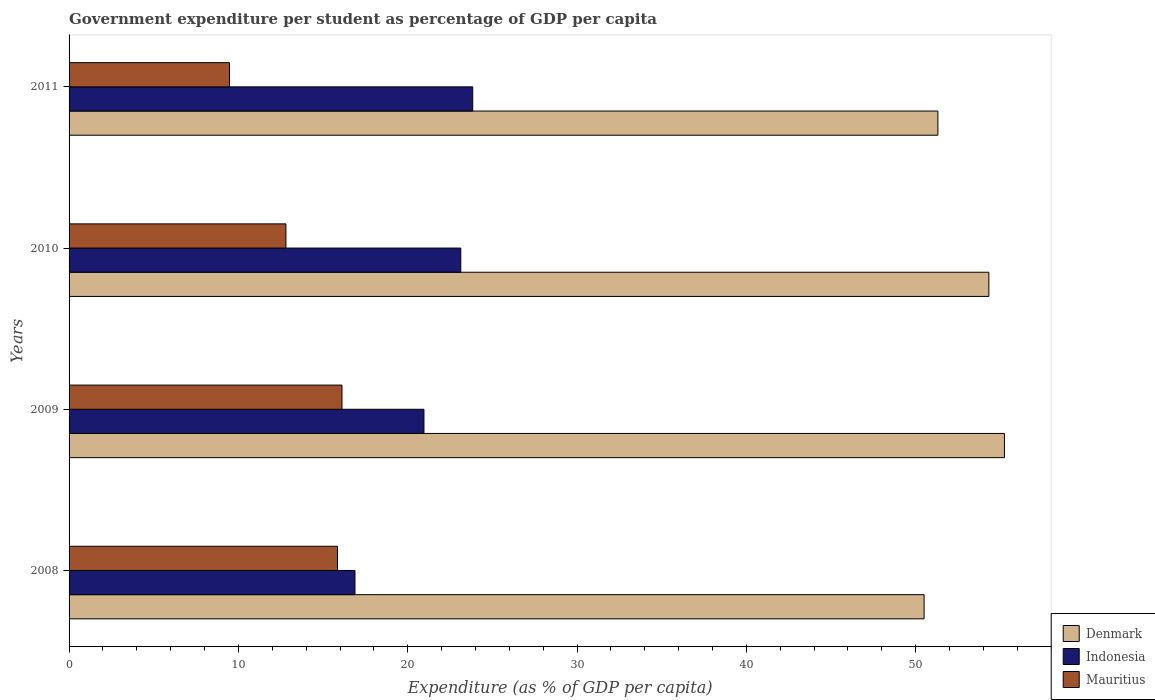Are the number of bars per tick equal to the number of legend labels?
Your answer should be very brief. Yes. What is the percentage of expenditure per student in Denmark in 2009?
Your answer should be very brief. 55.24. Across all years, what is the maximum percentage of expenditure per student in Mauritius?
Your answer should be very brief. 16.12. Across all years, what is the minimum percentage of expenditure per student in Mauritius?
Provide a succinct answer. 9.47. What is the total percentage of expenditure per student in Denmark in the graph?
Offer a very short reply. 211.37. What is the difference between the percentage of expenditure per student in Indonesia in 2009 and that in 2011?
Provide a succinct answer. -2.88. What is the difference between the percentage of expenditure per student in Indonesia in 2010 and the percentage of expenditure per student in Denmark in 2008?
Your answer should be very brief. -27.36. What is the average percentage of expenditure per student in Mauritius per year?
Keep it short and to the point. 13.56. In the year 2011, what is the difference between the percentage of expenditure per student in Indonesia and percentage of expenditure per student in Denmark?
Keep it short and to the point. -27.47. What is the ratio of the percentage of expenditure per student in Denmark in 2010 to that in 2011?
Offer a very short reply. 1.06. Is the percentage of expenditure per student in Denmark in 2009 less than that in 2011?
Offer a very short reply. No. What is the difference between the highest and the second highest percentage of expenditure per student in Indonesia?
Your answer should be compact. 0.7. What is the difference between the highest and the lowest percentage of expenditure per student in Mauritius?
Provide a succinct answer. 6.64. Is the sum of the percentage of expenditure per student in Denmark in 2008 and 2011 greater than the maximum percentage of expenditure per student in Mauritius across all years?
Your response must be concise. Yes. What does the 2nd bar from the top in 2011 represents?
Make the answer very short. Indonesia. What does the 3rd bar from the bottom in 2011 represents?
Provide a succinct answer. Mauritius. How many years are there in the graph?
Make the answer very short. 4. Are the values on the major ticks of X-axis written in scientific E-notation?
Give a very brief answer. No. How many legend labels are there?
Your answer should be very brief. 3. What is the title of the graph?
Keep it short and to the point. Government expenditure per student as percentage of GDP per capita. Does "Sub-Saharan Africa (developing only)" appear as one of the legend labels in the graph?
Your answer should be compact. No. What is the label or title of the X-axis?
Ensure brevity in your answer.  Expenditure (as % of GDP per capita). What is the Expenditure (as % of GDP per capita) in Denmark in 2008?
Your answer should be compact. 50.5. What is the Expenditure (as % of GDP per capita) in Indonesia in 2008?
Your answer should be very brief. 16.89. What is the Expenditure (as % of GDP per capita) of Mauritius in 2008?
Give a very brief answer. 15.85. What is the Expenditure (as % of GDP per capita) of Denmark in 2009?
Your response must be concise. 55.24. What is the Expenditure (as % of GDP per capita) of Indonesia in 2009?
Your answer should be compact. 20.96. What is the Expenditure (as % of GDP per capita) in Mauritius in 2009?
Your response must be concise. 16.12. What is the Expenditure (as % of GDP per capita) of Denmark in 2010?
Make the answer very short. 54.32. What is the Expenditure (as % of GDP per capita) of Indonesia in 2010?
Provide a succinct answer. 23.13. What is the Expenditure (as % of GDP per capita) in Mauritius in 2010?
Make the answer very short. 12.81. What is the Expenditure (as % of GDP per capita) of Denmark in 2011?
Your response must be concise. 51.31. What is the Expenditure (as % of GDP per capita) in Indonesia in 2011?
Your answer should be compact. 23.84. What is the Expenditure (as % of GDP per capita) in Mauritius in 2011?
Your response must be concise. 9.47. Across all years, what is the maximum Expenditure (as % of GDP per capita) in Denmark?
Provide a short and direct response. 55.24. Across all years, what is the maximum Expenditure (as % of GDP per capita) of Indonesia?
Give a very brief answer. 23.84. Across all years, what is the maximum Expenditure (as % of GDP per capita) in Mauritius?
Your response must be concise. 16.12. Across all years, what is the minimum Expenditure (as % of GDP per capita) of Denmark?
Your answer should be very brief. 50.5. Across all years, what is the minimum Expenditure (as % of GDP per capita) of Indonesia?
Offer a terse response. 16.89. Across all years, what is the minimum Expenditure (as % of GDP per capita) in Mauritius?
Your answer should be compact. 9.47. What is the total Expenditure (as % of GDP per capita) in Denmark in the graph?
Your answer should be compact. 211.37. What is the total Expenditure (as % of GDP per capita) of Indonesia in the graph?
Provide a short and direct response. 84.82. What is the total Expenditure (as % of GDP per capita) in Mauritius in the graph?
Offer a terse response. 54.25. What is the difference between the Expenditure (as % of GDP per capita) of Denmark in 2008 and that in 2009?
Offer a terse response. -4.74. What is the difference between the Expenditure (as % of GDP per capita) in Indonesia in 2008 and that in 2009?
Give a very brief answer. -4.07. What is the difference between the Expenditure (as % of GDP per capita) in Mauritius in 2008 and that in 2009?
Your answer should be compact. -0.27. What is the difference between the Expenditure (as % of GDP per capita) in Denmark in 2008 and that in 2010?
Provide a succinct answer. -3.82. What is the difference between the Expenditure (as % of GDP per capita) in Indonesia in 2008 and that in 2010?
Offer a terse response. -6.25. What is the difference between the Expenditure (as % of GDP per capita) in Mauritius in 2008 and that in 2010?
Provide a succinct answer. 3.04. What is the difference between the Expenditure (as % of GDP per capita) in Denmark in 2008 and that in 2011?
Ensure brevity in your answer.  -0.81. What is the difference between the Expenditure (as % of GDP per capita) of Indonesia in 2008 and that in 2011?
Offer a terse response. -6.95. What is the difference between the Expenditure (as % of GDP per capita) of Mauritius in 2008 and that in 2011?
Offer a terse response. 6.38. What is the difference between the Expenditure (as % of GDP per capita) in Denmark in 2009 and that in 2010?
Your answer should be compact. 0.92. What is the difference between the Expenditure (as % of GDP per capita) in Indonesia in 2009 and that in 2010?
Offer a terse response. -2.17. What is the difference between the Expenditure (as % of GDP per capita) in Mauritius in 2009 and that in 2010?
Keep it short and to the point. 3.31. What is the difference between the Expenditure (as % of GDP per capita) in Denmark in 2009 and that in 2011?
Your response must be concise. 3.93. What is the difference between the Expenditure (as % of GDP per capita) of Indonesia in 2009 and that in 2011?
Offer a very short reply. -2.88. What is the difference between the Expenditure (as % of GDP per capita) of Mauritius in 2009 and that in 2011?
Your answer should be very brief. 6.64. What is the difference between the Expenditure (as % of GDP per capita) of Denmark in 2010 and that in 2011?
Provide a succinct answer. 3.01. What is the difference between the Expenditure (as % of GDP per capita) in Indonesia in 2010 and that in 2011?
Provide a succinct answer. -0.7. What is the difference between the Expenditure (as % of GDP per capita) of Mauritius in 2010 and that in 2011?
Your answer should be compact. 3.33. What is the difference between the Expenditure (as % of GDP per capita) of Denmark in 2008 and the Expenditure (as % of GDP per capita) of Indonesia in 2009?
Ensure brevity in your answer.  29.54. What is the difference between the Expenditure (as % of GDP per capita) of Denmark in 2008 and the Expenditure (as % of GDP per capita) of Mauritius in 2009?
Give a very brief answer. 34.38. What is the difference between the Expenditure (as % of GDP per capita) of Indonesia in 2008 and the Expenditure (as % of GDP per capita) of Mauritius in 2009?
Provide a short and direct response. 0.77. What is the difference between the Expenditure (as % of GDP per capita) in Denmark in 2008 and the Expenditure (as % of GDP per capita) in Indonesia in 2010?
Keep it short and to the point. 27.36. What is the difference between the Expenditure (as % of GDP per capita) in Denmark in 2008 and the Expenditure (as % of GDP per capita) in Mauritius in 2010?
Ensure brevity in your answer.  37.69. What is the difference between the Expenditure (as % of GDP per capita) in Indonesia in 2008 and the Expenditure (as % of GDP per capita) in Mauritius in 2010?
Make the answer very short. 4.08. What is the difference between the Expenditure (as % of GDP per capita) of Denmark in 2008 and the Expenditure (as % of GDP per capita) of Indonesia in 2011?
Your answer should be very brief. 26.66. What is the difference between the Expenditure (as % of GDP per capita) in Denmark in 2008 and the Expenditure (as % of GDP per capita) in Mauritius in 2011?
Your response must be concise. 41.02. What is the difference between the Expenditure (as % of GDP per capita) in Indonesia in 2008 and the Expenditure (as % of GDP per capita) in Mauritius in 2011?
Your answer should be compact. 7.41. What is the difference between the Expenditure (as % of GDP per capita) in Denmark in 2009 and the Expenditure (as % of GDP per capita) in Indonesia in 2010?
Offer a very short reply. 32.11. What is the difference between the Expenditure (as % of GDP per capita) in Denmark in 2009 and the Expenditure (as % of GDP per capita) in Mauritius in 2010?
Your answer should be compact. 42.43. What is the difference between the Expenditure (as % of GDP per capita) in Indonesia in 2009 and the Expenditure (as % of GDP per capita) in Mauritius in 2010?
Provide a succinct answer. 8.15. What is the difference between the Expenditure (as % of GDP per capita) in Denmark in 2009 and the Expenditure (as % of GDP per capita) in Indonesia in 2011?
Your response must be concise. 31.4. What is the difference between the Expenditure (as % of GDP per capita) of Denmark in 2009 and the Expenditure (as % of GDP per capita) of Mauritius in 2011?
Provide a succinct answer. 45.77. What is the difference between the Expenditure (as % of GDP per capita) of Indonesia in 2009 and the Expenditure (as % of GDP per capita) of Mauritius in 2011?
Ensure brevity in your answer.  11.49. What is the difference between the Expenditure (as % of GDP per capita) in Denmark in 2010 and the Expenditure (as % of GDP per capita) in Indonesia in 2011?
Offer a terse response. 30.48. What is the difference between the Expenditure (as % of GDP per capita) in Denmark in 2010 and the Expenditure (as % of GDP per capita) in Mauritius in 2011?
Offer a very short reply. 44.85. What is the difference between the Expenditure (as % of GDP per capita) of Indonesia in 2010 and the Expenditure (as % of GDP per capita) of Mauritius in 2011?
Give a very brief answer. 13.66. What is the average Expenditure (as % of GDP per capita) of Denmark per year?
Make the answer very short. 52.84. What is the average Expenditure (as % of GDP per capita) in Indonesia per year?
Offer a terse response. 21.2. What is the average Expenditure (as % of GDP per capita) in Mauritius per year?
Ensure brevity in your answer.  13.56. In the year 2008, what is the difference between the Expenditure (as % of GDP per capita) of Denmark and Expenditure (as % of GDP per capita) of Indonesia?
Your response must be concise. 33.61. In the year 2008, what is the difference between the Expenditure (as % of GDP per capita) of Denmark and Expenditure (as % of GDP per capita) of Mauritius?
Give a very brief answer. 34.65. In the year 2008, what is the difference between the Expenditure (as % of GDP per capita) in Indonesia and Expenditure (as % of GDP per capita) in Mauritius?
Keep it short and to the point. 1.03. In the year 2009, what is the difference between the Expenditure (as % of GDP per capita) in Denmark and Expenditure (as % of GDP per capita) in Indonesia?
Make the answer very short. 34.28. In the year 2009, what is the difference between the Expenditure (as % of GDP per capita) in Denmark and Expenditure (as % of GDP per capita) in Mauritius?
Provide a short and direct response. 39.12. In the year 2009, what is the difference between the Expenditure (as % of GDP per capita) in Indonesia and Expenditure (as % of GDP per capita) in Mauritius?
Offer a very short reply. 4.84. In the year 2010, what is the difference between the Expenditure (as % of GDP per capita) of Denmark and Expenditure (as % of GDP per capita) of Indonesia?
Give a very brief answer. 31.19. In the year 2010, what is the difference between the Expenditure (as % of GDP per capita) of Denmark and Expenditure (as % of GDP per capita) of Mauritius?
Provide a short and direct response. 41.51. In the year 2010, what is the difference between the Expenditure (as % of GDP per capita) in Indonesia and Expenditure (as % of GDP per capita) in Mauritius?
Offer a very short reply. 10.33. In the year 2011, what is the difference between the Expenditure (as % of GDP per capita) of Denmark and Expenditure (as % of GDP per capita) of Indonesia?
Offer a very short reply. 27.47. In the year 2011, what is the difference between the Expenditure (as % of GDP per capita) in Denmark and Expenditure (as % of GDP per capita) in Mauritius?
Provide a succinct answer. 41.84. In the year 2011, what is the difference between the Expenditure (as % of GDP per capita) in Indonesia and Expenditure (as % of GDP per capita) in Mauritius?
Give a very brief answer. 14.36. What is the ratio of the Expenditure (as % of GDP per capita) in Denmark in 2008 to that in 2009?
Offer a very short reply. 0.91. What is the ratio of the Expenditure (as % of GDP per capita) in Indonesia in 2008 to that in 2009?
Your answer should be very brief. 0.81. What is the ratio of the Expenditure (as % of GDP per capita) of Mauritius in 2008 to that in 2009?
Offer a very short reply. 0.98. What is the ratio of the Expenditure (as % of GDP per capita) in Denmark in 2008 to that in 2010?
Offer a terse response. 0.93. What is the ratio of the Expenditure (as % of GDP per capita) of Indonesia in 2008 to that in 2010?
Make the answer very short. 0.73. What is the ratio of the Expenditure (as % of GDP per capita) in Mauritius in 2008 to that in 2010?
Provide a succinct answer. 1.24. What is the ratio of the Expenditure (as % of GDP per capita) in Denmark in 2008 to that in 2011?
Your answer should be compact. 0.98. What is the ratio of the Expenditure (as % of GDP per capita) of Indonesia in 2008 to that in 2011?
Your response must be concise. 0.71. What is the ratio of the Expenditure (as % of GDP per capita) in Mauritius in 2008 to that in 2011?
Your answer should be very brief. 1.67. What is the ratio of the Expenditure (as % of GDP per capita) in Denmark in 2009 to that in 2010?
Your response must be concise. 1.02. What is the ratio of the Expenditure (as % of GDP per capita) in Indonesia in 2009 to that in 2010?
Your answer should be compact. 0.91. What is the ratio of the Expenditure (as % of GDP per capita) of Mauritius in 2009 to that in 2010?
Offer a terse response. 1.26. What is the ratio of the Expenditure (as % of GDP per capita) of Denmark in 2009 to that in 2011?
Keep it short and to the point. 1.08. What is the ratio of the Expenditure (as % of GDP per capita) in Indonesia in 2009 to that in 2011?
Your answer should be compact. 0.88. What is the ratio of the Expenditure (as % of GDP per capita) of Mauritius in 2009 to that in 2011?
Your answer should be compact. 1.7. What is the ratio of the Expenditure (as % of GDP per capita) of Denmark in 2010 to that in 2011?
Give a very brief answer. 1.06. What is the ratio of the Expenditure (as % of GDP per capita) of Indonesia in 2010 to that in 2011?
Ensure brevity in your answer.  0.97. What is the ratio of the Expenditure (as % of GDP per capita) in Mauritius in 2010 to that in 2011?
Offer a very short reply. 1.35. What is the difference between the highest and the second highest Expenditure (as % of GDP per capita) in Denmark?
Offer a terse response. 0.92. What is the difference between the highest and the second highest Expenditure (as % of GDP per capita) in Indonesia?
Provide a succinct answer. 0.7. What is the difference between the highest and the second highest Expenditure (as % of GDP per capita) in Mauritius?
Your response must be concise. 0.27. What is the difference between the highest and the lowest Expenditure (as % of GDP per capita) of Denmark?
Ensure brevity in your answer.  4.74. What is the difference between the highest and the lowest Expenditure (as % of GDP per capita) of Indonesia?
Your response must be concise. 6.95. What is the difference between the highest and the lowest Expenditure (as % of GDP per capita) in Mauritius?
Your answer should be compact. 6.64. 